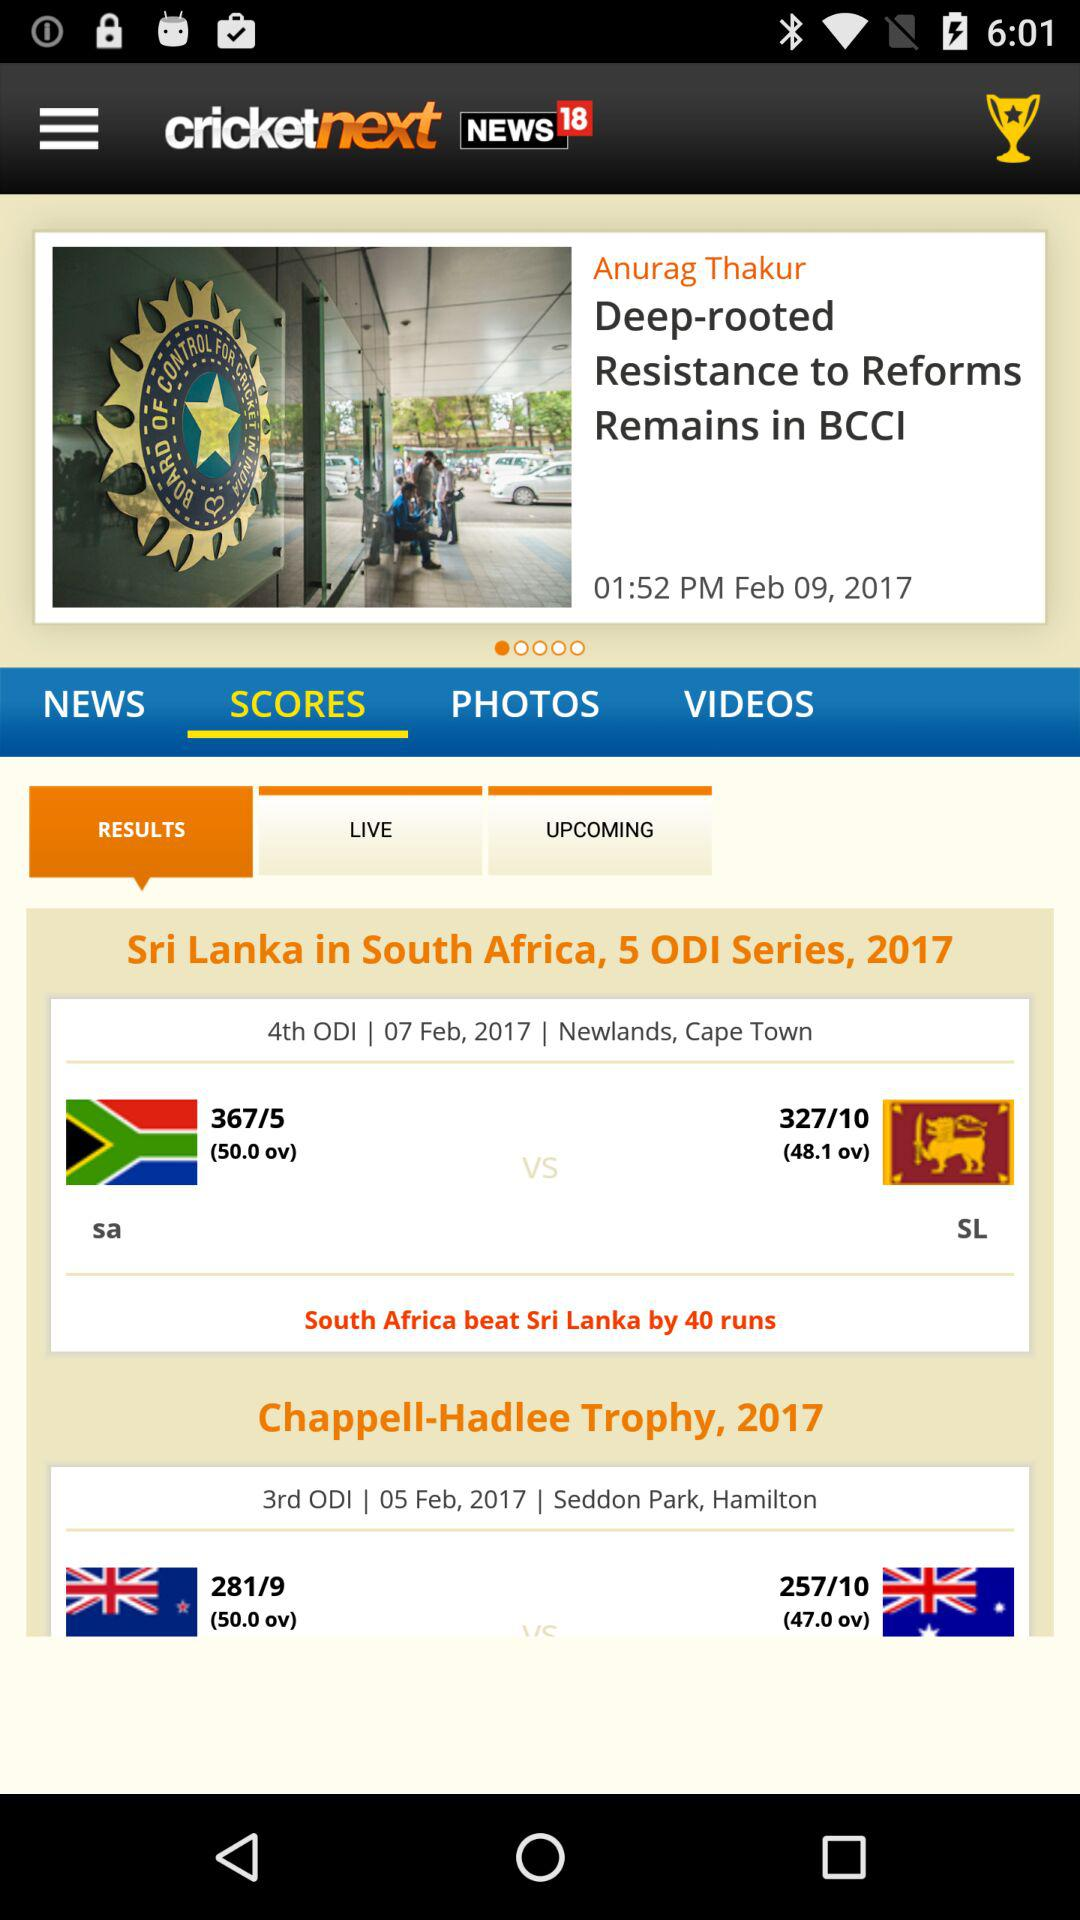What is the date of the 3rd ODI match? The date of the 3rd ODI match is February 5, 2017. 